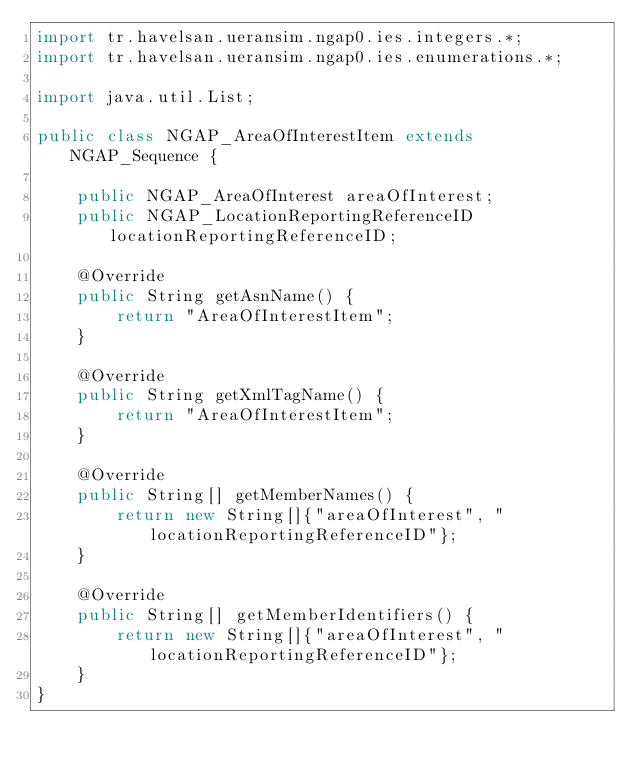<code> <loc_0><loc_0><loc_500><loc_500><_Java_>import tr.havelsan.ueransim.ngap0.ies.integers.*;
import tr.havelsan.ueransim.ngap0.ies.enumerations.*;

import java.util.List;

public class NGAP_AreaOfInterestItem extends NGAP_Sequence {

    public NGAP_AreaOfInterest areaOfInterest;
    public NGAP_LocationReportingReferenceID locationReportingReferenceID;

    @Override
    public String getAsnName() {
        return "AreaOfInterestItem";
    }

    @Override
    public String getXmlTagName() {
        return "AreaOfInterestItem";
    }

    @Override
    public String[] getMemberNames() {
        return new String[]{"areaOfInterest", "locationReportingReferenceID"};
    }

    @Override
    public String[] getMemberIdentifiers() {
        return new String[]{"areaOfInterest", "locationReportingReferenceID"};
    }
}
</code> 